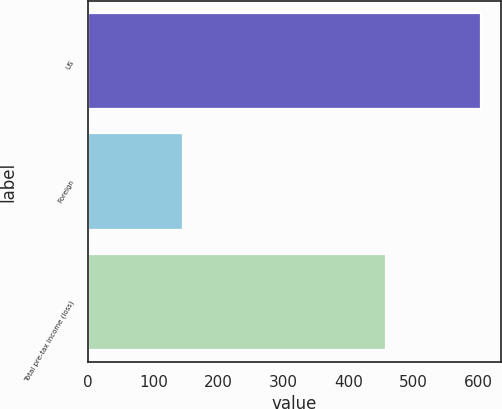Convert chart. <chart><loc_0><loc_0><loc_500><loc_500><bar_chart><fcel>US<fcel>Foreign<fcel>Total pre-tax income (loss)<nl><fcel>604<fcel>146<fcel>458<nl></chart> 